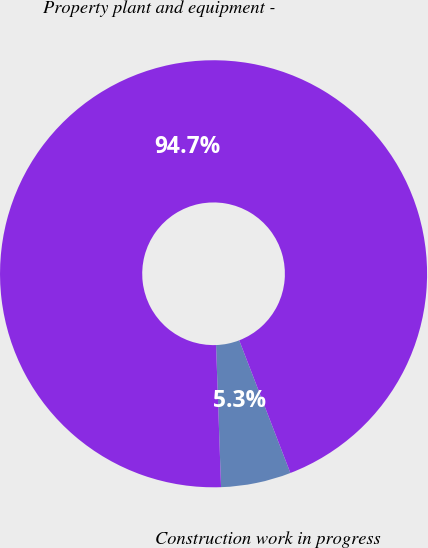Convert chart. <chart><loc_0><loc_0><loc_500><loc_500><pie_chart><fcel>Construction work in progress<fcel>Property plant and equipment -<nl><fcel>5.3%<fcel>94.7%<nl></chart> 